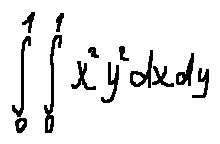Convert formula to latex. <formula><loc_0><loc_0><loc_500><loc_500>\int \lim i t s _ { 0 } ^ { 1 } \int \lim i t s _ { 0 } ^ { 1 } x ^ { 2 } y ^ { 2 } d x d y</formula> 